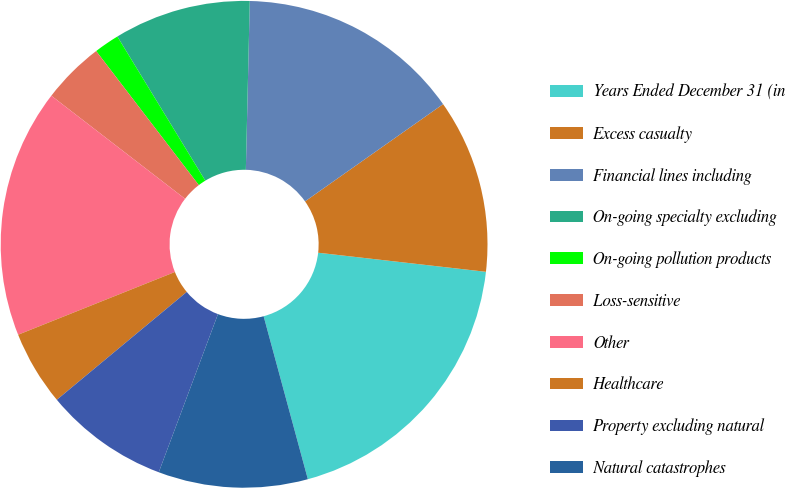Convert chart. <chart><loc_0><loc_0><loc_500><loc_500><pie_chart><fcel>Years Ended December 31 (in<fcel>Excess casualty<fcel>Financial lines including<fcel>On-going specialty excluding<fcel>On-going pollution products<fcel>Loss-sensitive<fcel>Other<fcel>Healthcare<fcel>Property excluding natural<fcel>Natural catastrophes<nl><fcel>18.98%<fcel>11.57%<fcel>14.86%<fcel>9.09%<fcel>1.68%<fcel>4.15%<fcel>16.51%<fcel>4.97%<fcel>8.27%<fcel>9.92%<nl></chart> 